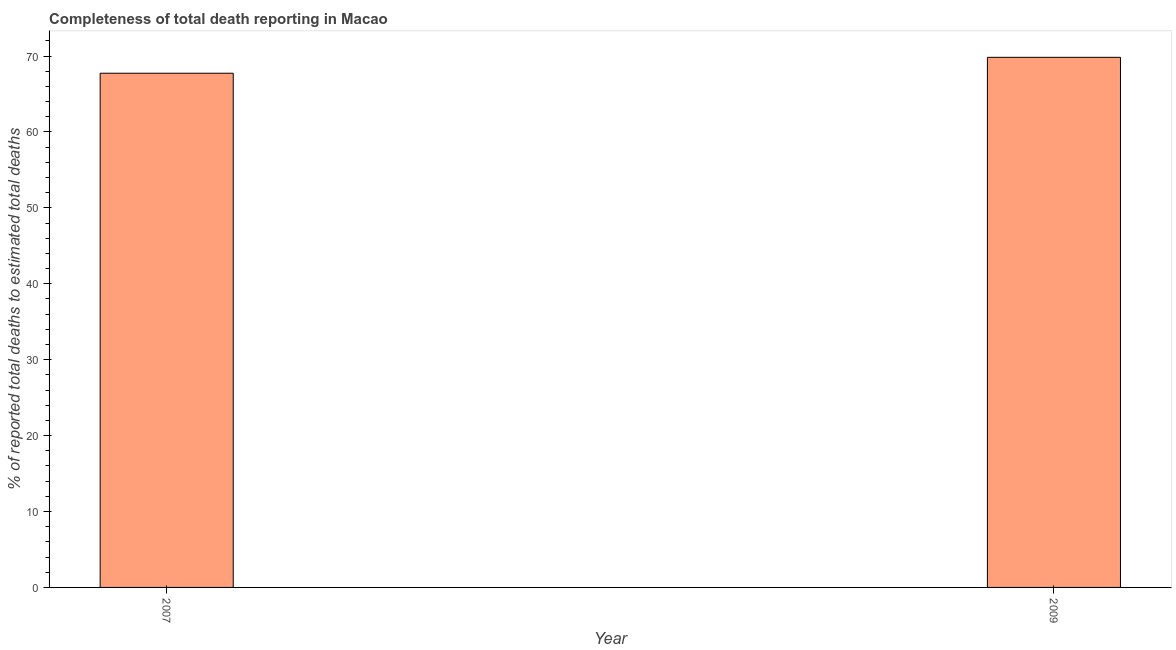Does the graph contain grids?
Give a very brief answer. No. What is the title of the graph?
Provide a short and direct response. Completeness of total death reporting in Macao. What is the label or title of the Y-axis?
Keep it short and to the point. % of reported total deaths to estimated total deaths. What is the completeness of total death reports in 2009?
Offer a very short reply. 69.83. Across all years, what is the maximum completeness of total death reports?
Your answer should be compact. 69.83. Across all years, what is the minimum completeness of total death reports?
Make the answer very short. 67.73. In which year was the completeness of total death reports maximum?
Ensure brevity in your answer.  2009. In which year was the completeness of total death reports minimum?
Provide a succinct answer. 2007. What is the sum of the completeness of total death reports?
Your answer should be compact. 137.56. What is the difference between the completeness of total death reports in 2007 and 2009?
Make the answer very short. -2.09. What is the average completeness of total death reports per year?
Make the answer very short. 68.78. What is the median completeness of total death reports?
Provide a short and direct response. 68.78. In how many years, is the completeness of total death reports greater than 34 %?
Provide a short and direct response. 2. What is the ratio of the completeness of total death reports in 2007 to that in 2009?
Your response must be concise. 0.97. Is the completeness of total death reports in 2007 less than that in 2009?
Provide a succinct answer. Yes. In how many years, is the completeness of total death reports greater than the average completeness of total death reports taken over all years?
Give a very brief answer. 1. Are all the bars in the graph horizontal?
Provide a short and direct response. No. How many years are there in the graph?
Your answer should be very brief. 2. What is the difference between two consecutive major ticks on the Y-axis?
Offer a very short reply. 10. What is the % of reported total deaths to estimated total deaths in 2007?
Offer a very short reply. 67.73. What is the % of reported total deaths to estimated total deaths in 2009?
Offer a terse response. 69.83. What is the difference between the % of reported total deaths to estimated total deaths in 2007 and 2009?
Make the answer very short. -2.09. 